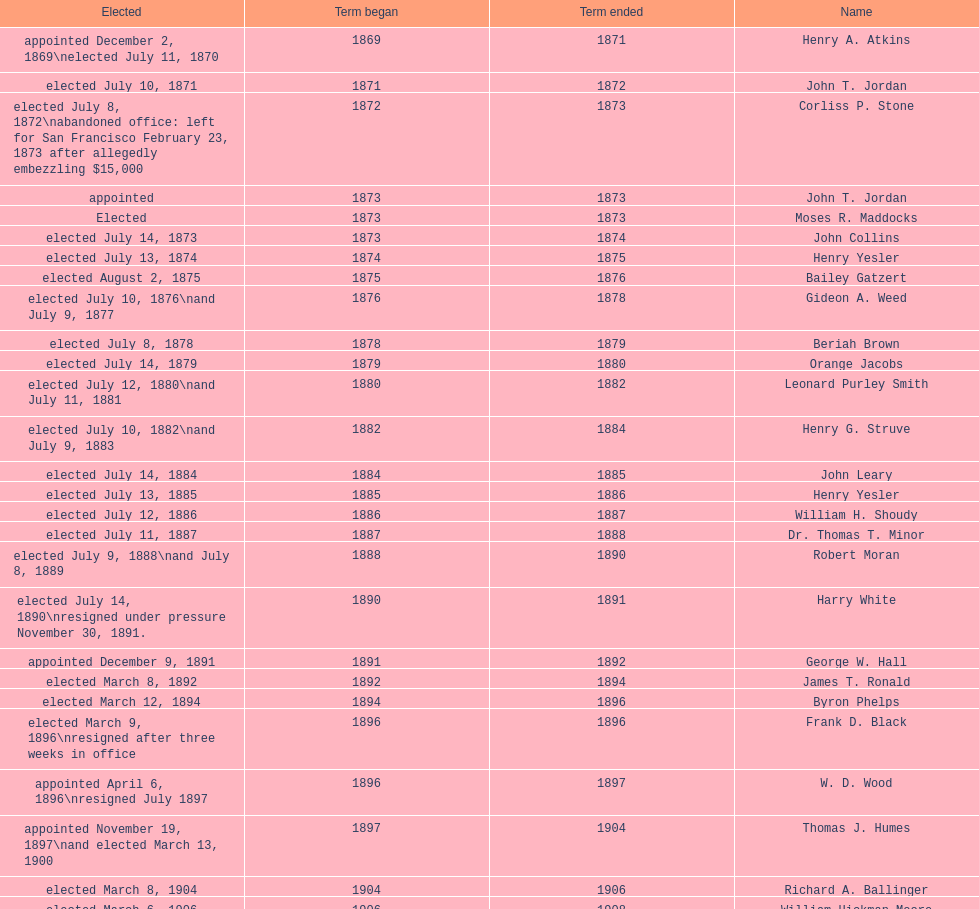Who was the first mayor in the 1900's? Richard A. Ballinger. 